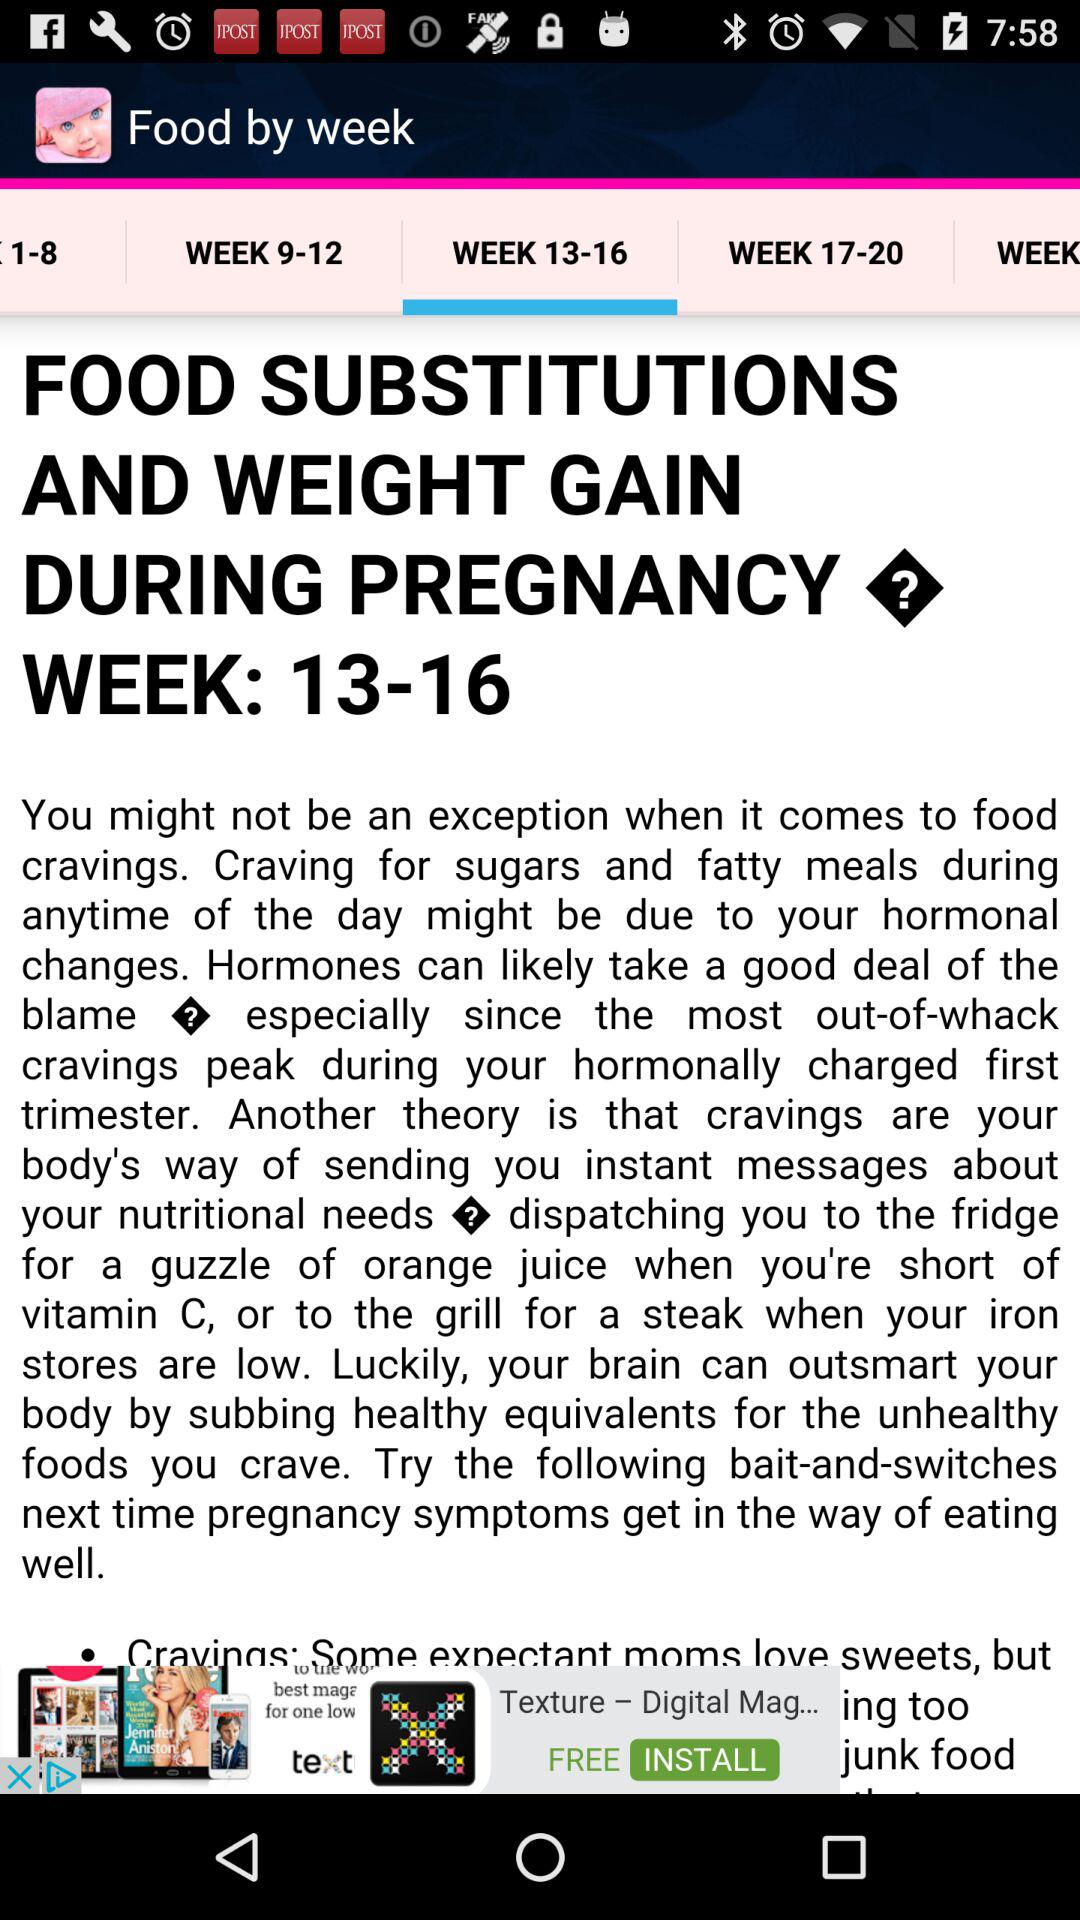What is the title of the content? The title of the content is "FOOD SUBSTITUTIONS AND WEIGHT GAIN DURING PREGNANCY?". 